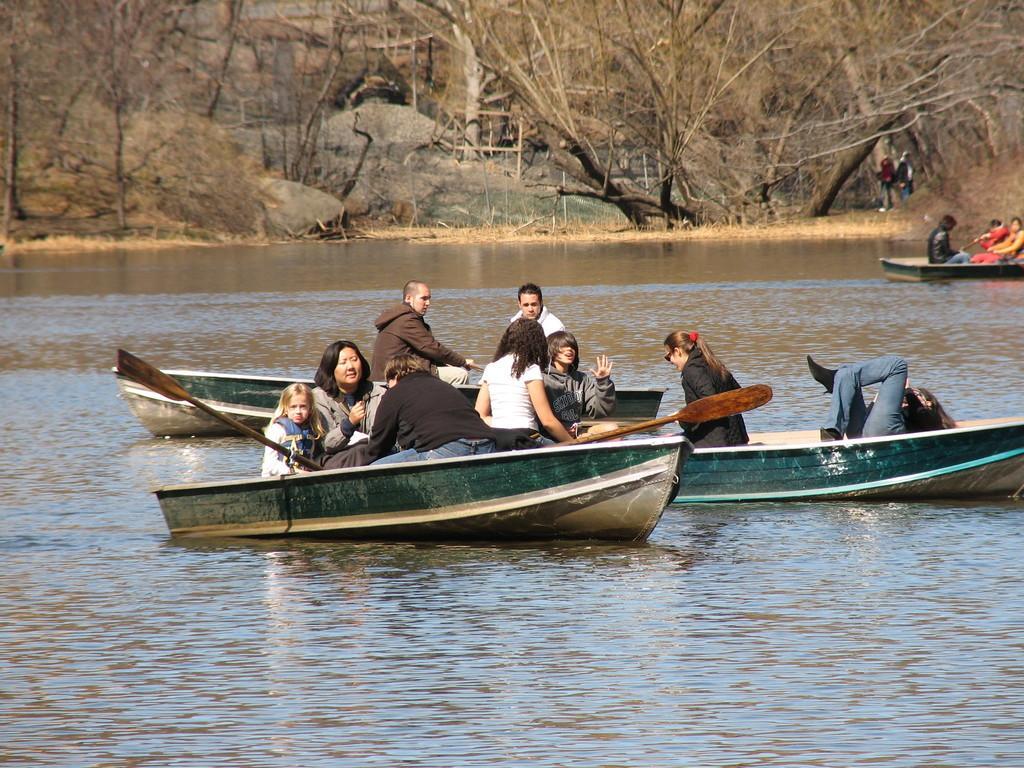Can you describe this image briefly? In the picture there is water, there are many boats present on the water, there are many people present sitting on the boats, there are trees, there are rocks present, there are people present beside the trees. 